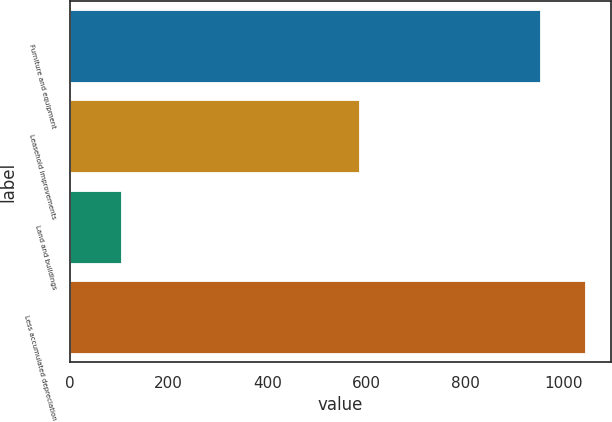Convert chart to OTSL. <chart><loc_0><loc_0><loc_500><loc_500><bar_chart><fcel>Furniture and equipment<fcel>Leasehold improvements<fcel>Land and buildings<fcel>Less accumulated depreciation<nl><fcel>952<fcel>584.9<fcel>104.1<fcel>1043.29<nl></chart> 